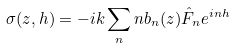Convert formula to latex. <formula><loc_0><loc_0><loc_500><loc_500>\sigma ( z , h ) = - i k \sum _ { n } n b _ { n } ( z ) \hat { F } _ { n } e ^ { i n h }</formula> 